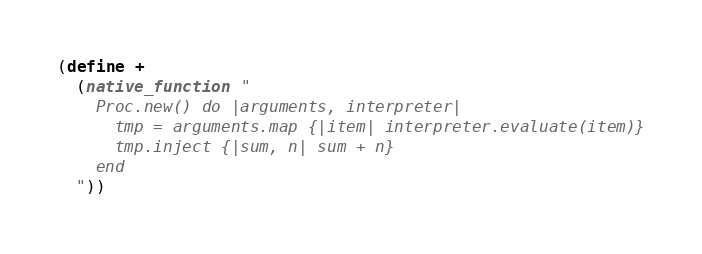<code> <loc_0><loc_0><loc_500><loc_500><_Scheme_>(define + 
  (native_function "
    Proc.new() do |arguments, interpreter|
      tmp = arguments.map {|item| interpreter.evaluate(item)}
      tmp.inject {|sum, n| sum + n}
    end
  "))</code> 